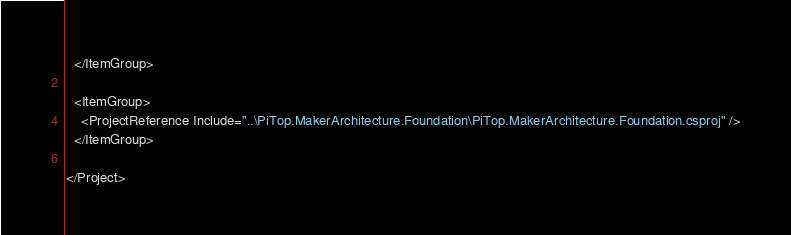<code> <loc_0><loc_0><loc_500><loc_500><_XML_>  </ItemGroup>

  <ItemGroup>
    <ProjectReference Include="..\PiTop.MakerArchitecture.Foundation\PiTop.MakerArchitecture.Foundation.csproj" />
  </ItemGroup>

</Project>
</code> 